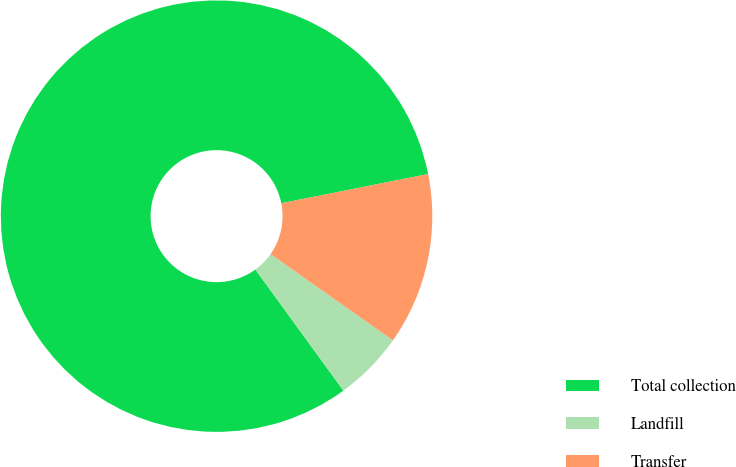<chart> <loc_0><loc_0><loc_500><loc_500><pie_chart><fcel>Total collection<fcel>Landfill<fcel>Transfer<nl><fcel>81.88%<fcel>5.23%<fcel>12.89%<nl></chart> 